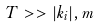<formula> <loc_0><loc_0><loc_500><loc_500>T > > | { k } _ { i } | , m</formula> 